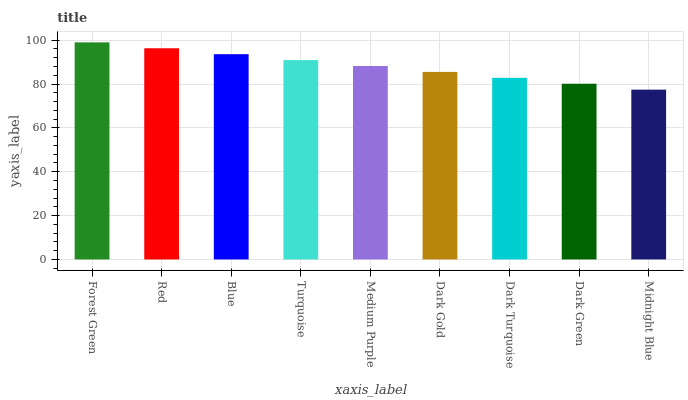Is Midnight Blue the minimum?
Answer yes or no. Yes. Is Forest Green the maximum?
Answer yes or no. Yes. Is Red the minimum?
Answer yes or no. No. Is Red the maximum?
Answer yes or no. No. Is Forest Green greater than Red?
Answer yes or no. Yes. Is Red less than Forest Green?
Answer yes or no. Yes. Is Red greater than Forest Green?
Answer yes or no. No. Is Forest Green less than Red?
Answer yes or no. No. Is Medium Purple the high median?
Answer yes or no. Yes. Is Medium Purple the low median?
Answer yes or no. Yes. Is Dark Gold the high median?
Answer yes or no. No. Is Blue the low median?
Answer yes or no. No. 